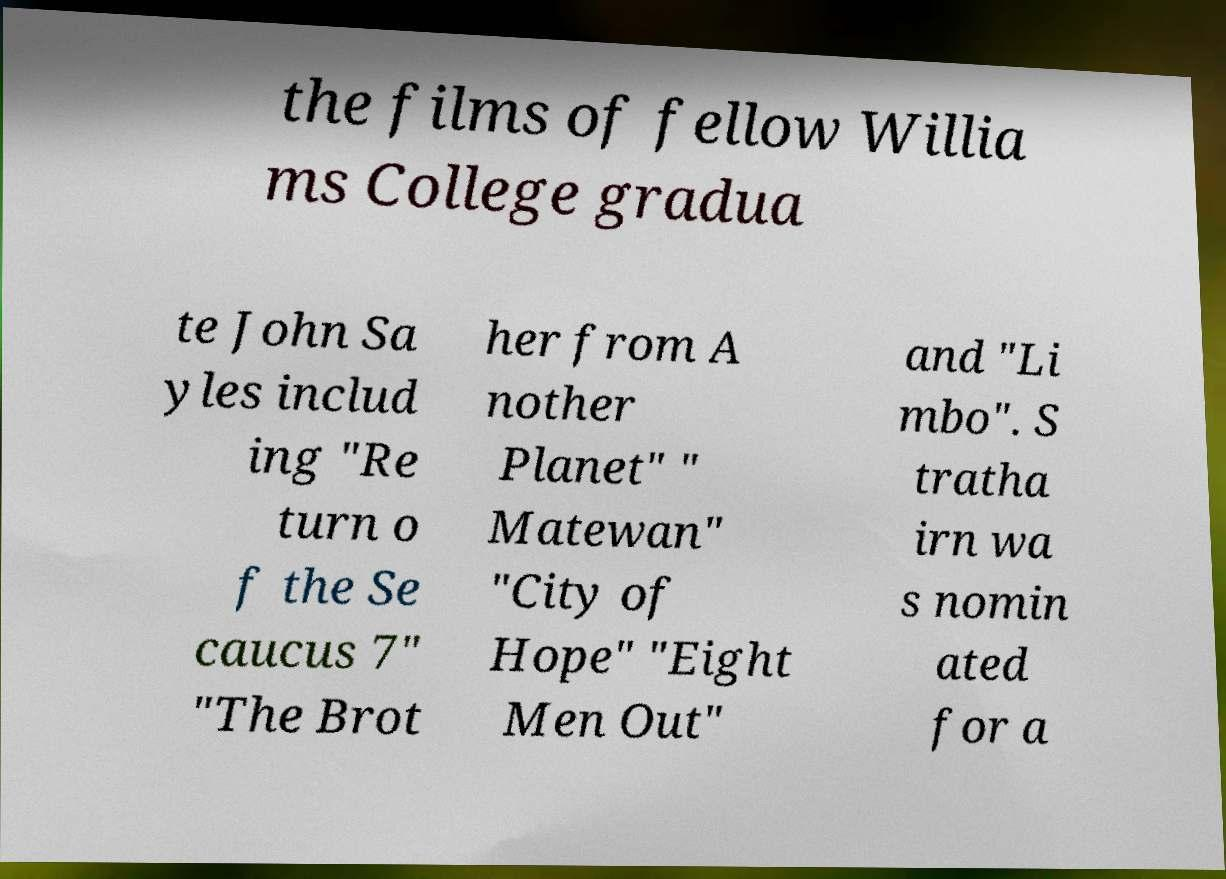What messages or text are displayed in this image? I need them in a readable, typed format. the films of fellow Willia ms College gradua te John Sa yles includ ing "Re turn o f the Se caucus 7" "The Brot her from A nother Planet" " Matewan" "City of Hope" "Eight Men Out" and "Li mbo". S tratha irn wa s nomin ated for a 